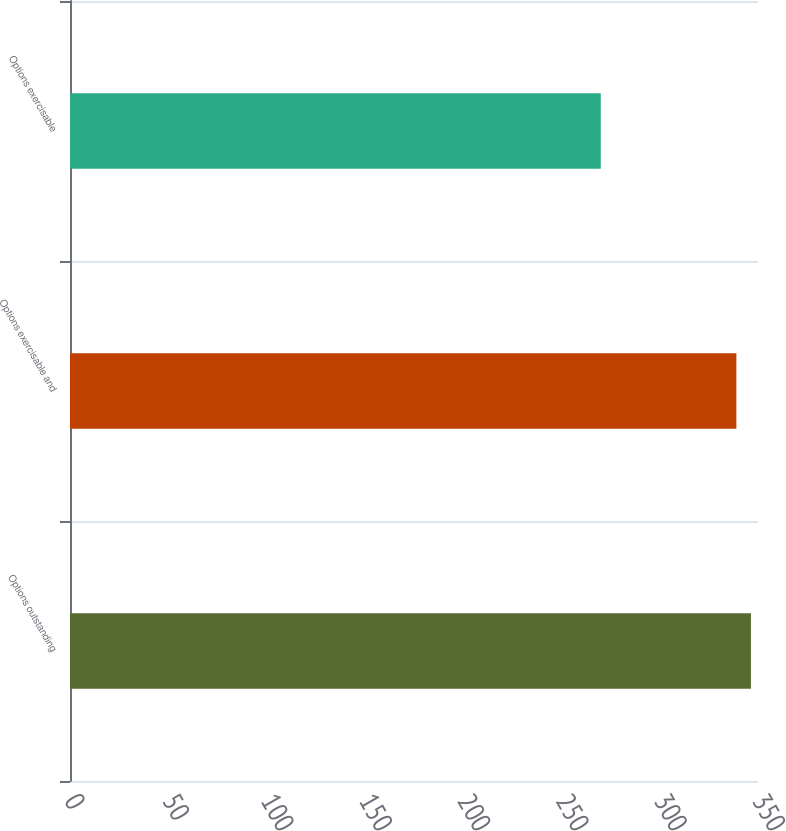Convert chart. <chart><loc_0><loc_0><loc_500><loc_500><bar_chart><fcel>Options outstanding<fcel>Options exercisable and<fcel>Options exercisable<nl><fcel>346.4<fcel>339<fcel>270<nl></chart> 